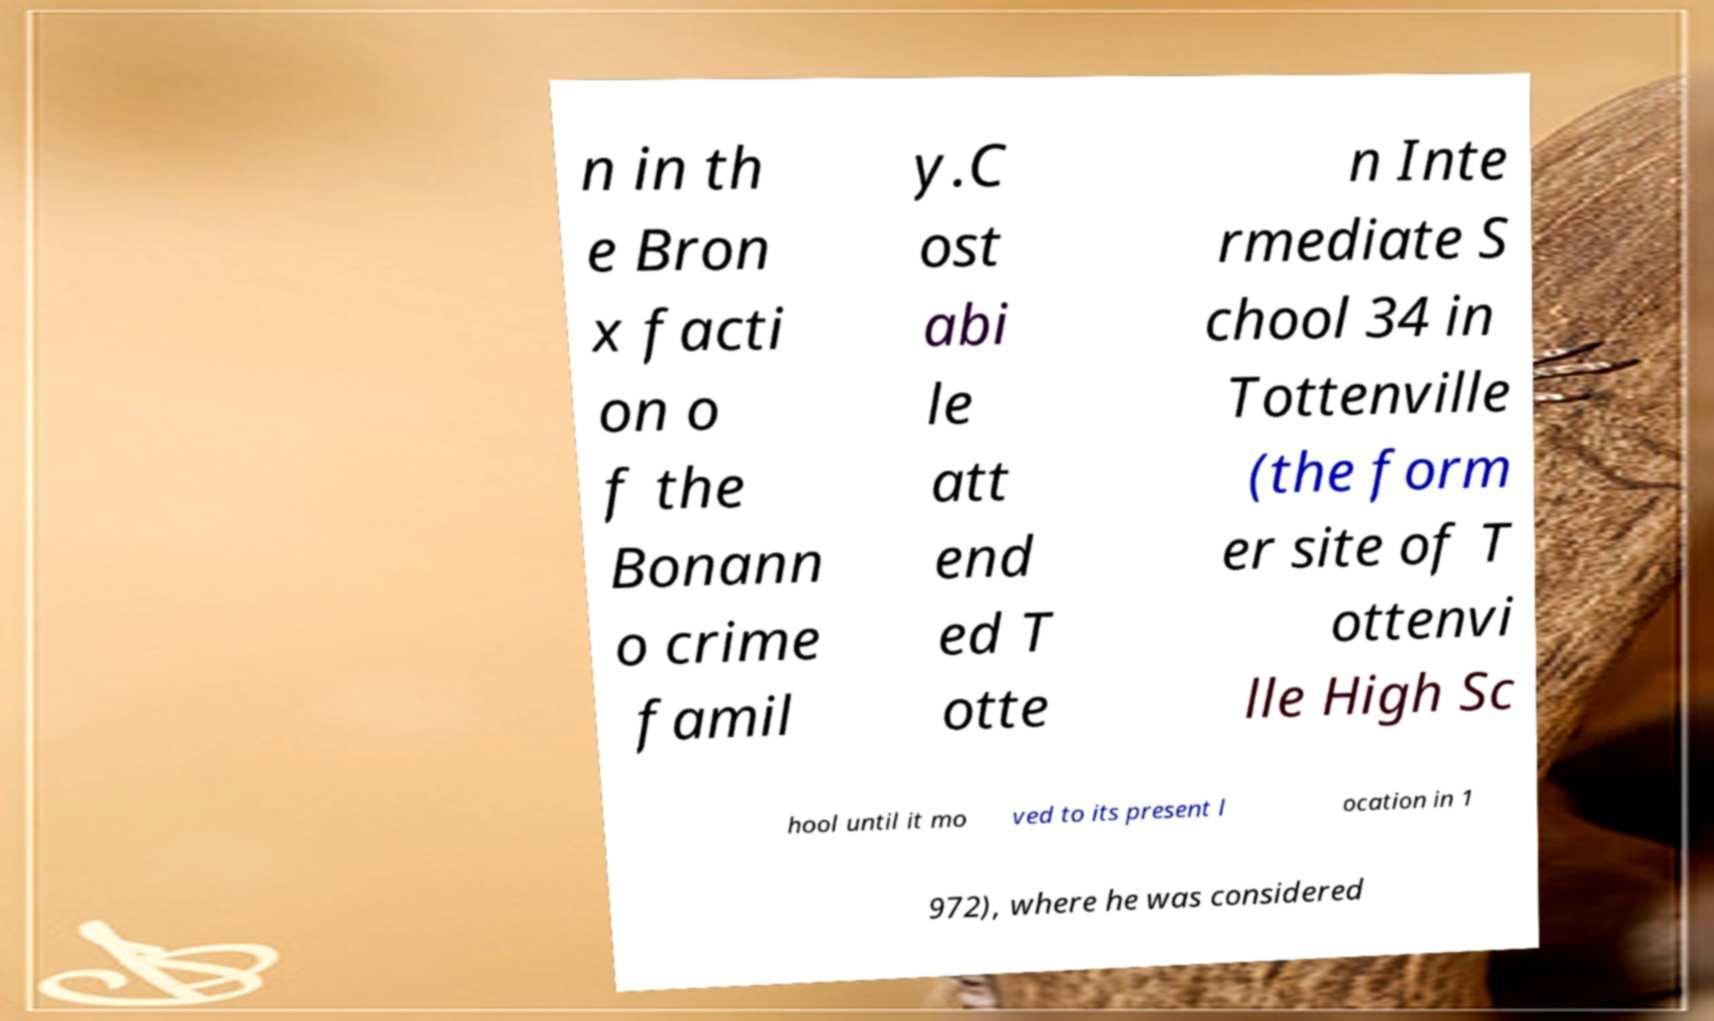Please read and relay the text visible in this image. What does it say? n in th e Bron x facti on o f the Bonann o crime famil y.C ost abi le att end ed T otte n Inte rmediate S chool 34 in Tottenville (the form er site of T ottenvi lle High Sc hool until it mo ved to its present l ocation in 1 972), where he was considered 